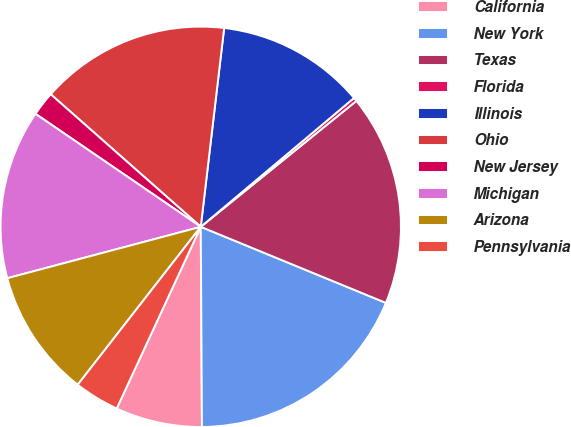Convert chart. <chart><loc_0><loc_0><loc_500><loc_500><pie_chart><fcel>California<fcel>New York<fcel>Texas<fcel>Florida<fcel>Illinois<fcel>Ohio<fcel>New Jersey<fcel>Michigan<fcel>Arizona<fcel>Pennsylvania<nl><fcel>6.99%<fcel>18.7%<fcel>17.03%<fcel>0.3%<fcel>12.01%<fcel>15.35%<fcel>1.97%<fcel>13.68%<fcel>10.33%<fcel>3.64%<nl></chart> 